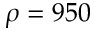Convert formula to latex. <formula><loc_0><loc_0><loc_500><loc_500>\rho = 9 5 0</formula> 